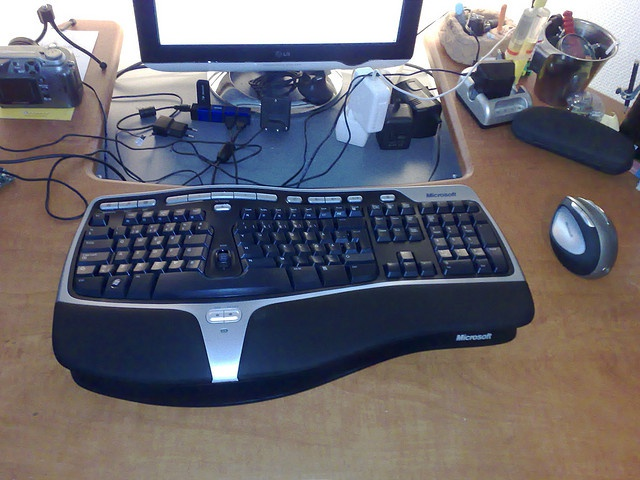Describe the objects in this image and their specific colors. I can see keyboard in white, black, navy, gray, and darkgray tones, tv in white, navy, darkgray, and darkblue tones, and mouse in white, navy, gray, black, and darkgray tones in this image. 